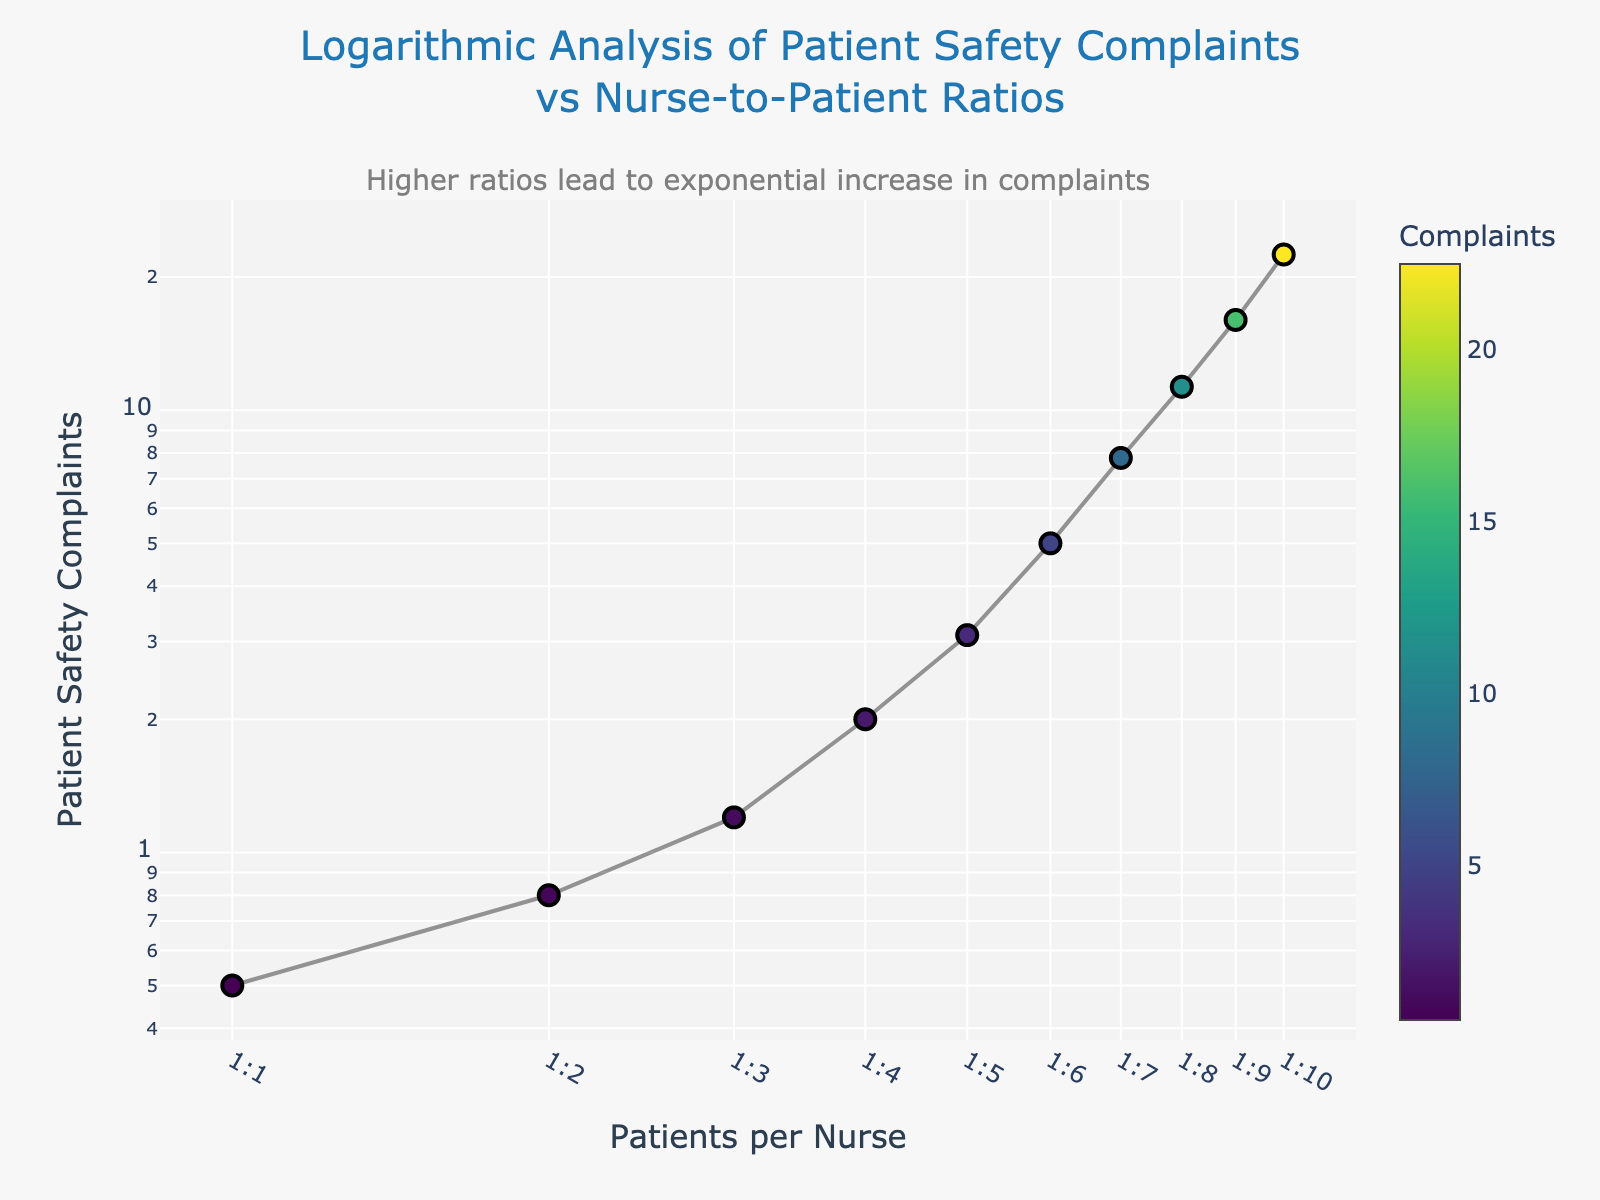What is the title of the plot? The title is usually found at the top of the chart. This plot is titled "Logarithmic Analysis of Patient Safety Complaints vs Nurse-to-Patient Ratios"
Answer: Logarithmic Analysis of Patient Safety Complaints vs Nurse-to-Patient Ratios How many data points are represented in the figure? Each marker represents a data point which corresponds to a specific Nurse-to-Patient Ratio and the number of Patient Safety Complaints. Counting them gives a total of 10 data points.
Answer: 10 What are the axes labels in the plot? The X-axis label is at the bottom and shows "Patients per Nurse," while the Y-axis label on the left side shows "Patient Safety Complaints."
Answer: Patients per Nurse, Patient Safety Complaints What does the color scale represent in the plot? The color scale is an additional visual aid usually explaining the range of color intensities used. In this plot, it is labelled "Complaints" and represents the number of Patient Safety Complaints.
Answer: Complaints By how much do patient complaints increase when the Nurse-to-Patient Ratio changes from 1:2 to 1:4? According to the plot, at a 1:2 ratio, complaints are at 0.8, and at a 1:4 ratio, complaints are at 2.0. Subtracting 0.8 from 2.0 gives an increase of 1.2 complaints.
Answer: 1.2 Which Nurse-to-Patient Ratio corresponds to the highest number of Patient Safety Complaints? Looking at the Y-axis and corresponding X-axis values, the highest number of Patient Safety Complaints (22.5) occurs at a Nurse-to-Patient Ratio of 1:10.
Answer: 1:10 Is the increase in complaints more significant between lower ratios (1:1 to 1:3) or higher ratios (1:8 to 1:10)? From 1:1 to 1:3, complaints increase from 0.5 to 1.2. From 1:8 to 1:10, they increase from 11.3 to 22.5. 0.7 < 11.2, so the jump is greater at higher ratios.
Answer: Higher ratios (1:8 to 1:10) What is the logarithmic trend observed in patient safety complaints as the nurse-to-patient ratio increases? As the Nurse-to-Patient Ratio increases, the Patient Safety Complaints increase exponentially, as shown by the steep curve in the log-log plot.
Answer: Exponential increase If the trend continues, what might you predict for a 1:11 Nurse-to-Patient Ratio? Considering the exponential trend, extrapolating suggests that the Patient Safety Complaints will likely be significantly higher than 22.5, though an exact figure would need further data for precise prediction.
Answer: Significantly higher than 22.5 